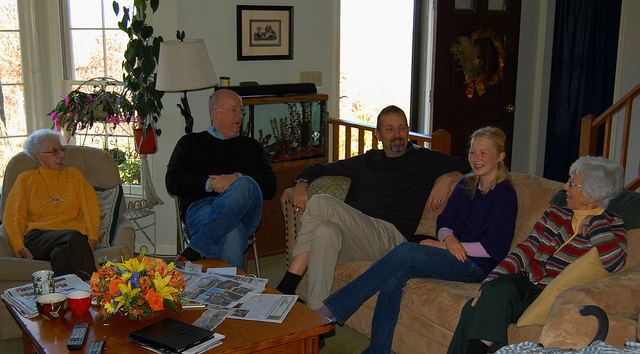<image>What kind of fruit can you see? There is no fruit in the image.
 What kind of fruit can you see? I am not sure what kind of fruit can be seen. It can be flowers, pineapple or none. 